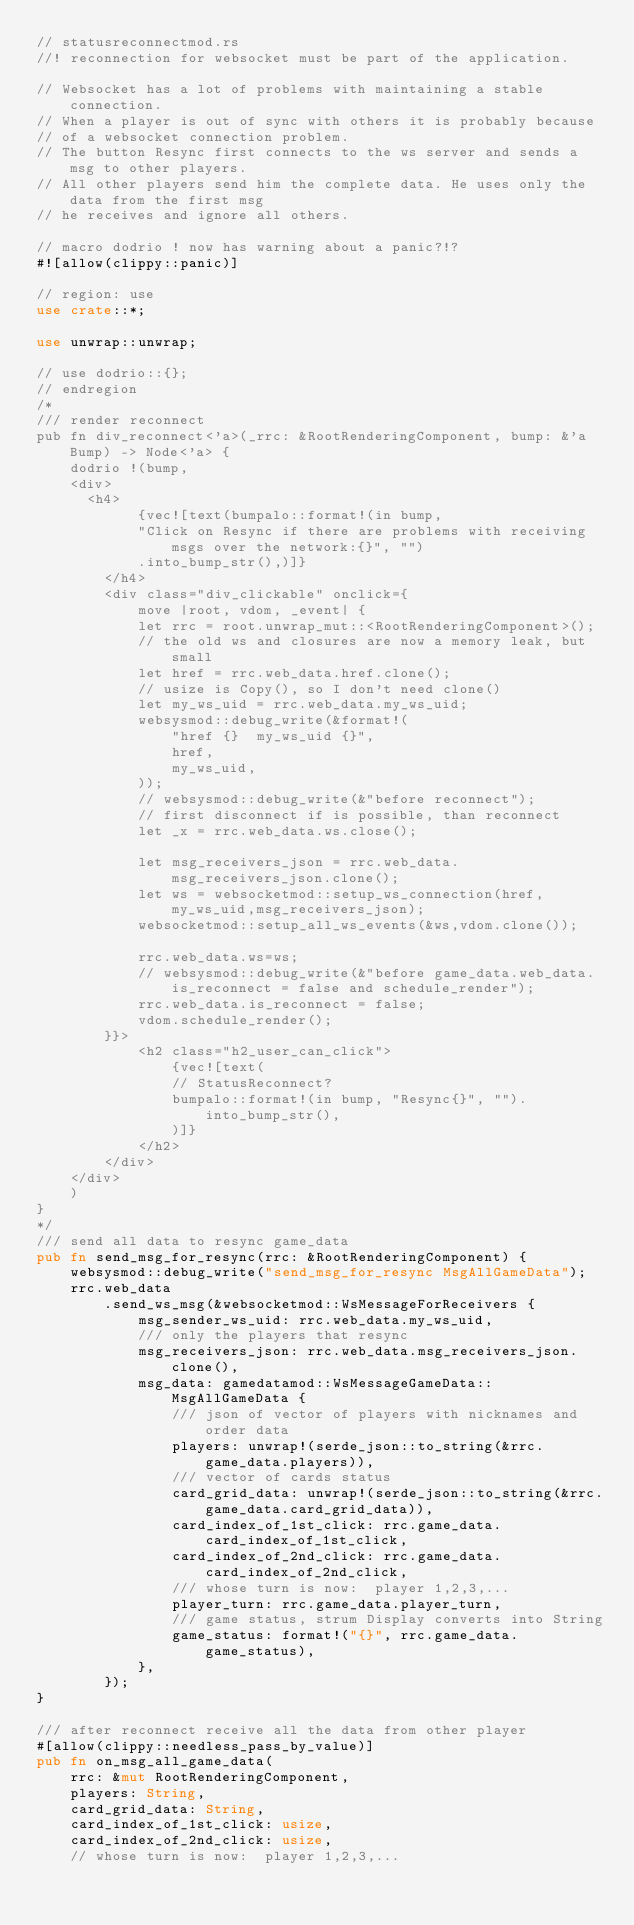Convert code to text. <code><loc_0><loc_0><loc_500><loc_500><_Rust_>// statusreconnectmod.rs
//! reconnection for websocket must be part of the application.

// Websocket has a lot of problems with maintaining a stable connection.
// When a player is out of sync with others it is probably because
// of a websocket connection problem.
// The button Resync first connects to the ws server and sends a msg to other players.
// All other players send him the complete data. He uses only the data from the first msg
// he receives and ignore all others.

// macro dodrio ! now has warning about a panic?!?
#![allow(clippy::panic)]

// region: use
use crate::*;

use unwrap::unwrap;

// use dodrio::{};
// endregion
/*
/// render reconnect
pub fn div_reconnect<'a>(_rrc: &RootRenderingComponent, bump: &'a Bump) -> Node<'a> {
    dodrio !(bump,
    <div>
      <h4>
            {vec![text(bumpalo::format!(in bump,
            "Click on Resync if there are problems with receiving msgs over the network:{}", "")
            .into_bump_str(),)]}
        </h4>
        <div class="div_clickable" onclick={
            move |root, vdom, _event| {
            let rrc = root.unwrap_mut::<RootRenderingComponent>();
            // the old ws and closures are now a memory leak, but small
            let href = rrc.web_data.href.clone();
            // usize is Copy(), so I don't need clone()
            let my_ws_uid = rrc.web_data.my_ws_uid;
            websysmod::debug_write(&format!(
                "href {}  my_ws_uid {}",
                href,
                my_ws_uid,
            ));
            // websysmod::debug_write(&"before reconnect");
            // first disconnect if is possible, than reconnect
            let _x = rrc.web_data.ws.close();

            let msg_receivers_json = rrc.web_data.msg_receivers_json.clone();
            let ws = websocketmod::setup_ws_connection(href, my_ws_uid,msg_receivers_json);
            websocketmod::setup_all_ws_events(&ws,vdom.clone());

            rrc.web_data.ws=ws;
            // websysmod::debug_write(&"before game_data.web_data.is_reconnect = false and schedule_render");
            rrc.web_data.is_reconnect = false;
            vdom.schedule_render();
        }}>
            <h2 class="h2_user_can_click">
                {vec![text(
                // StatusReconnect?
                bumpalo::format!(in bump, "Resync{}", "").into_bump_str(),
                )]}
            </h2>
        </div>
    </div>
    )
}
*/
/// send all data to resync game_data
pub fn send_msg_for_resync(rrc: &RootRenderingComponent) {
    websysmod::debug_write("send_msg_for_resync MsgAllGameData");
    rrc.web_data
        .send_ws_msg(&websocketmod::WsMessageForReceivers {
            msg_sender_ws_uid: rrc.web_data.my_ws_uid,
            /// only the players that resync
            msg_receivers_json: rrc.web_data.msg_receivers_json.clone(),
            msg_data: gamedatamod::WsMessageGameData::MsgAllGameData {
                /// json of vector of players with nicknames and order data
                players: unwrap!(serde_json::to_string(&rrc.game_data.players)),
                /// vector of cards status
                card_grid_data: unwrap!(serde_json::to_string(&rrc.game_data.card_grid_data)),
                card_index_of_1st_click: rrc.game_data.card_index_of_1st_click,
                card_index_of_2nd_click: rrc.game_data.card_index_of_2nd_click,
                /// whose turn is now:  player 1,2,3,...
                player_turn: rrc.game_data.player_turn,
                /// game status, strum Display converts into String
                game_status: format!("{}", rrc.game_data.game_status),
            },
        });
}

/// after reconnect receive all the data from other player
#[allow(clippy::needless_pass_by_value)]
pub fn on_msg_all_game_data(
    rrc: &mut RootRenderingComponent,
    players: String,
    card_grid_data: String,
    card_index_of_1st_click: usize,
    card_index_of_2nd_click: usize,
    // whose turn is now:  player 1,2,3,...</code> 